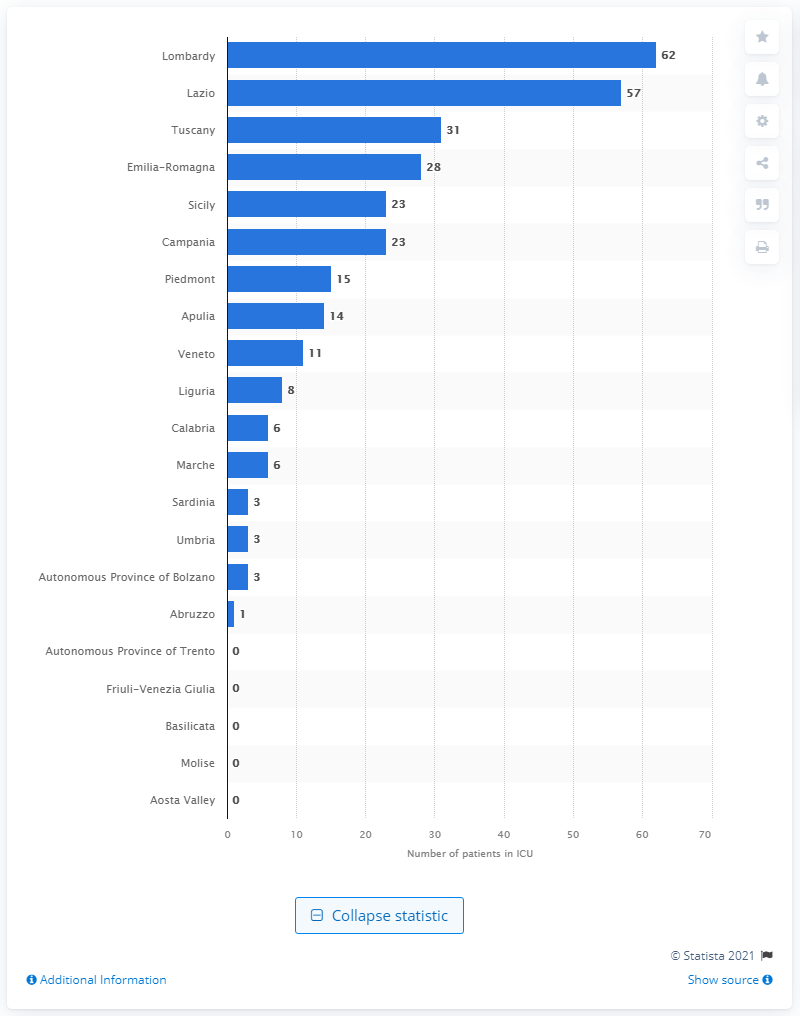Point out several critical features in this image. Lombardy had the highest number of COVID-19 cases out of all the regions in Italy. 